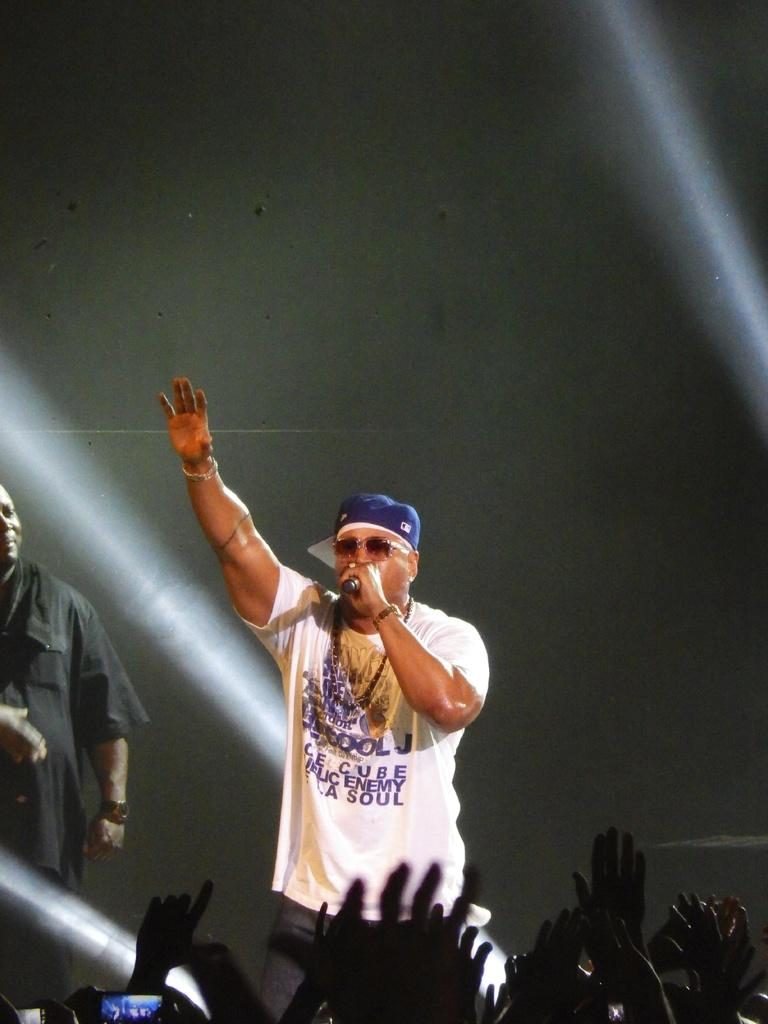<image>
Share a concise interpretation of the image provided. the singer is wearing a white tshirt with words like enemy and soul on it 